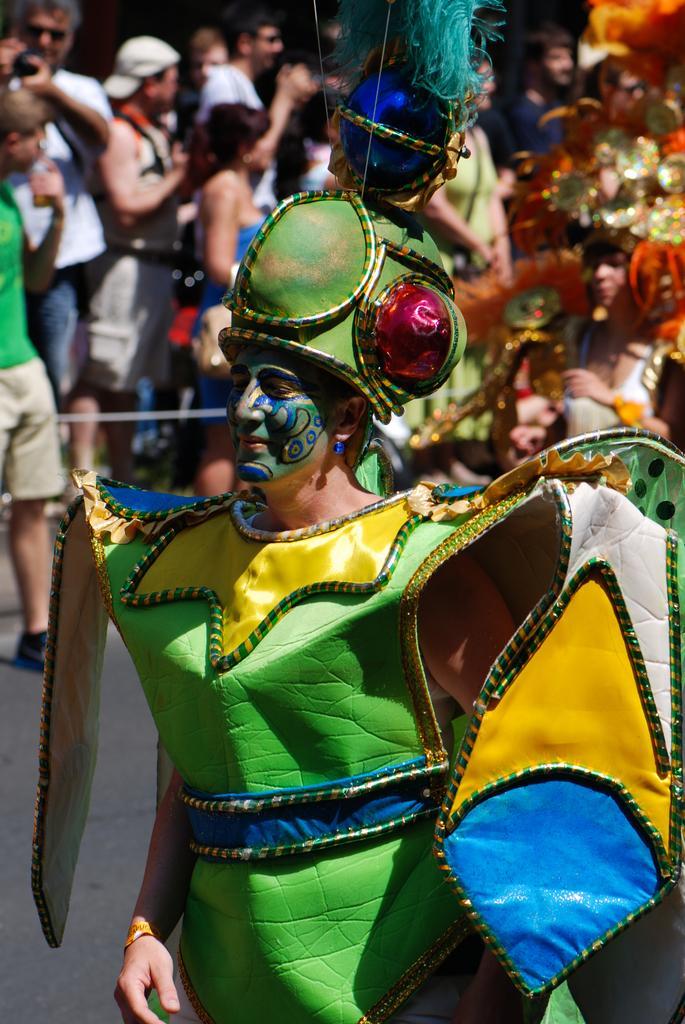Can you describe this image briefly? In this image we can see a person. In the background of the image there are some persons and other objects. 